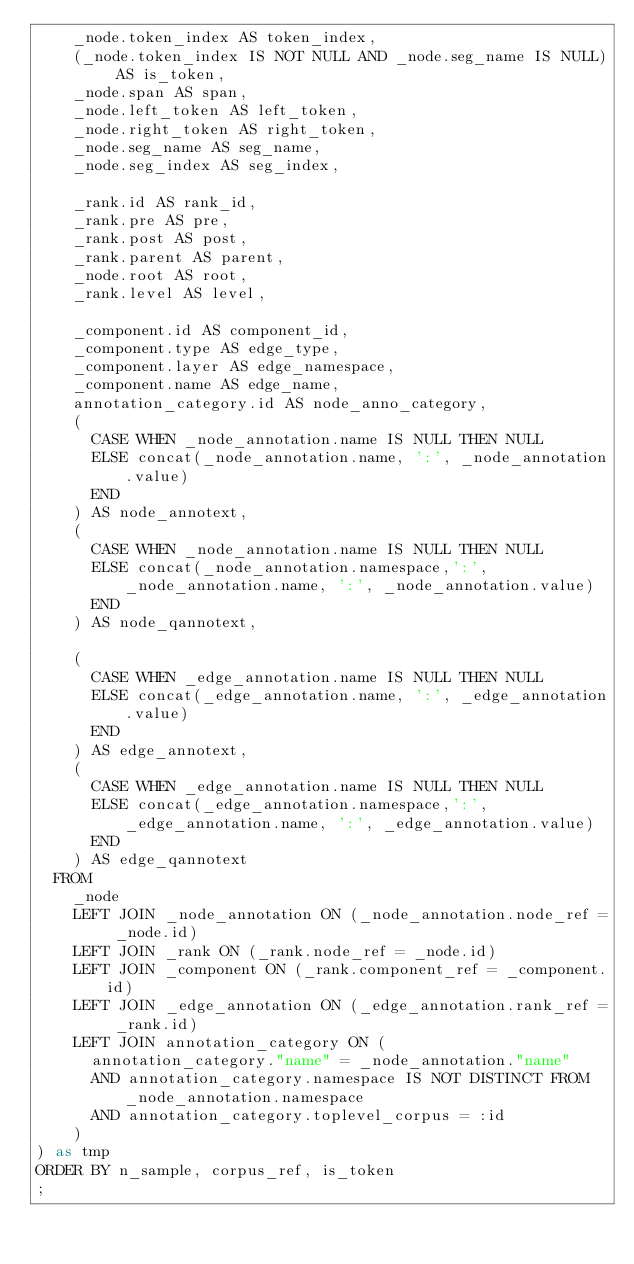<code> <loc_0><loc_0><loc_500><loc_500><_SQL_>    _node.token_index AS token_index,
    (_node.token_index IS NOT NULL AND _node.seg_name IS NULL) AS is_token,
    _node.span AS span,
    _node.left_token AS left_token,
    _node.right_token AS right_token,
    _node.seg_name AS seg_name,
    _node.seg_index AS seg_index,

    _rank.id AS rank_id,
    _rank.pre AS pre,
    _rank.post AS post,
    _rank.parent AS parent,
    _node.root AS root,
    _rank.level AS level,

    _component.id AS component_id,
    _component.type AS edge_type,
    _component.layer AS edge_namespace,
    _component.name AS edge_name,
    annotation_category.id AS node_anno_category,
    (
      CASE WHEN _node_annotation.name IS NULL THEN NULL
      ELSE concat(_node_annotation.name, ':', _node_annotation.value)
      END
    ) AS node_annotext,
    (
      CASE WHEN _node_annotation.name IS NULL THEN NULL
      ELSE concat(_node_annotation.namespace,':', _node_annotation.name, ':', _node_annotation.value)
      END
    ) AS node_qannotext,

    (
      CASE WHEN _edge_annotation.name IS NULL THEN NULL
      ELSE concat(_edge_annotation.name, ':', _edge_annotation.value)
      END
    ) AS edge_annotext,
    (
      CASE WHEN _edge_annotation.name IS NULL THEN NULL
      ELSE concat(_edge_annotation.namespace,':', _edge_annotation.name, ':', _edge_annotation.value)
      END
    ) AS edge_qannotext
  FROM
    _node
    LEFT JOIN _node_annotation ON (_node_annotation.node_ref = _node.id)
    LEFT JOIN _rank ON (_rank.node_ref = _node.id)
    LEFT JOIN _component ON (_rank.component_ref = _component.id)
    LEFT JOIN _edge_annotation ON (_edge_annotation.rank_ref = _rank.id)
    LEFT JOIN annotation_category ON (
      annotation_category."name" = _node_annotation."name" 
      AND annotation_category.namespace IS NOT DISTINCT FROM _node_annotation.namespace
      AND annotation_category.toplevel_corpus = :id
    )
) as tmp
ORDER BY n_sample, corpus_ref, is_token
;
</code> 